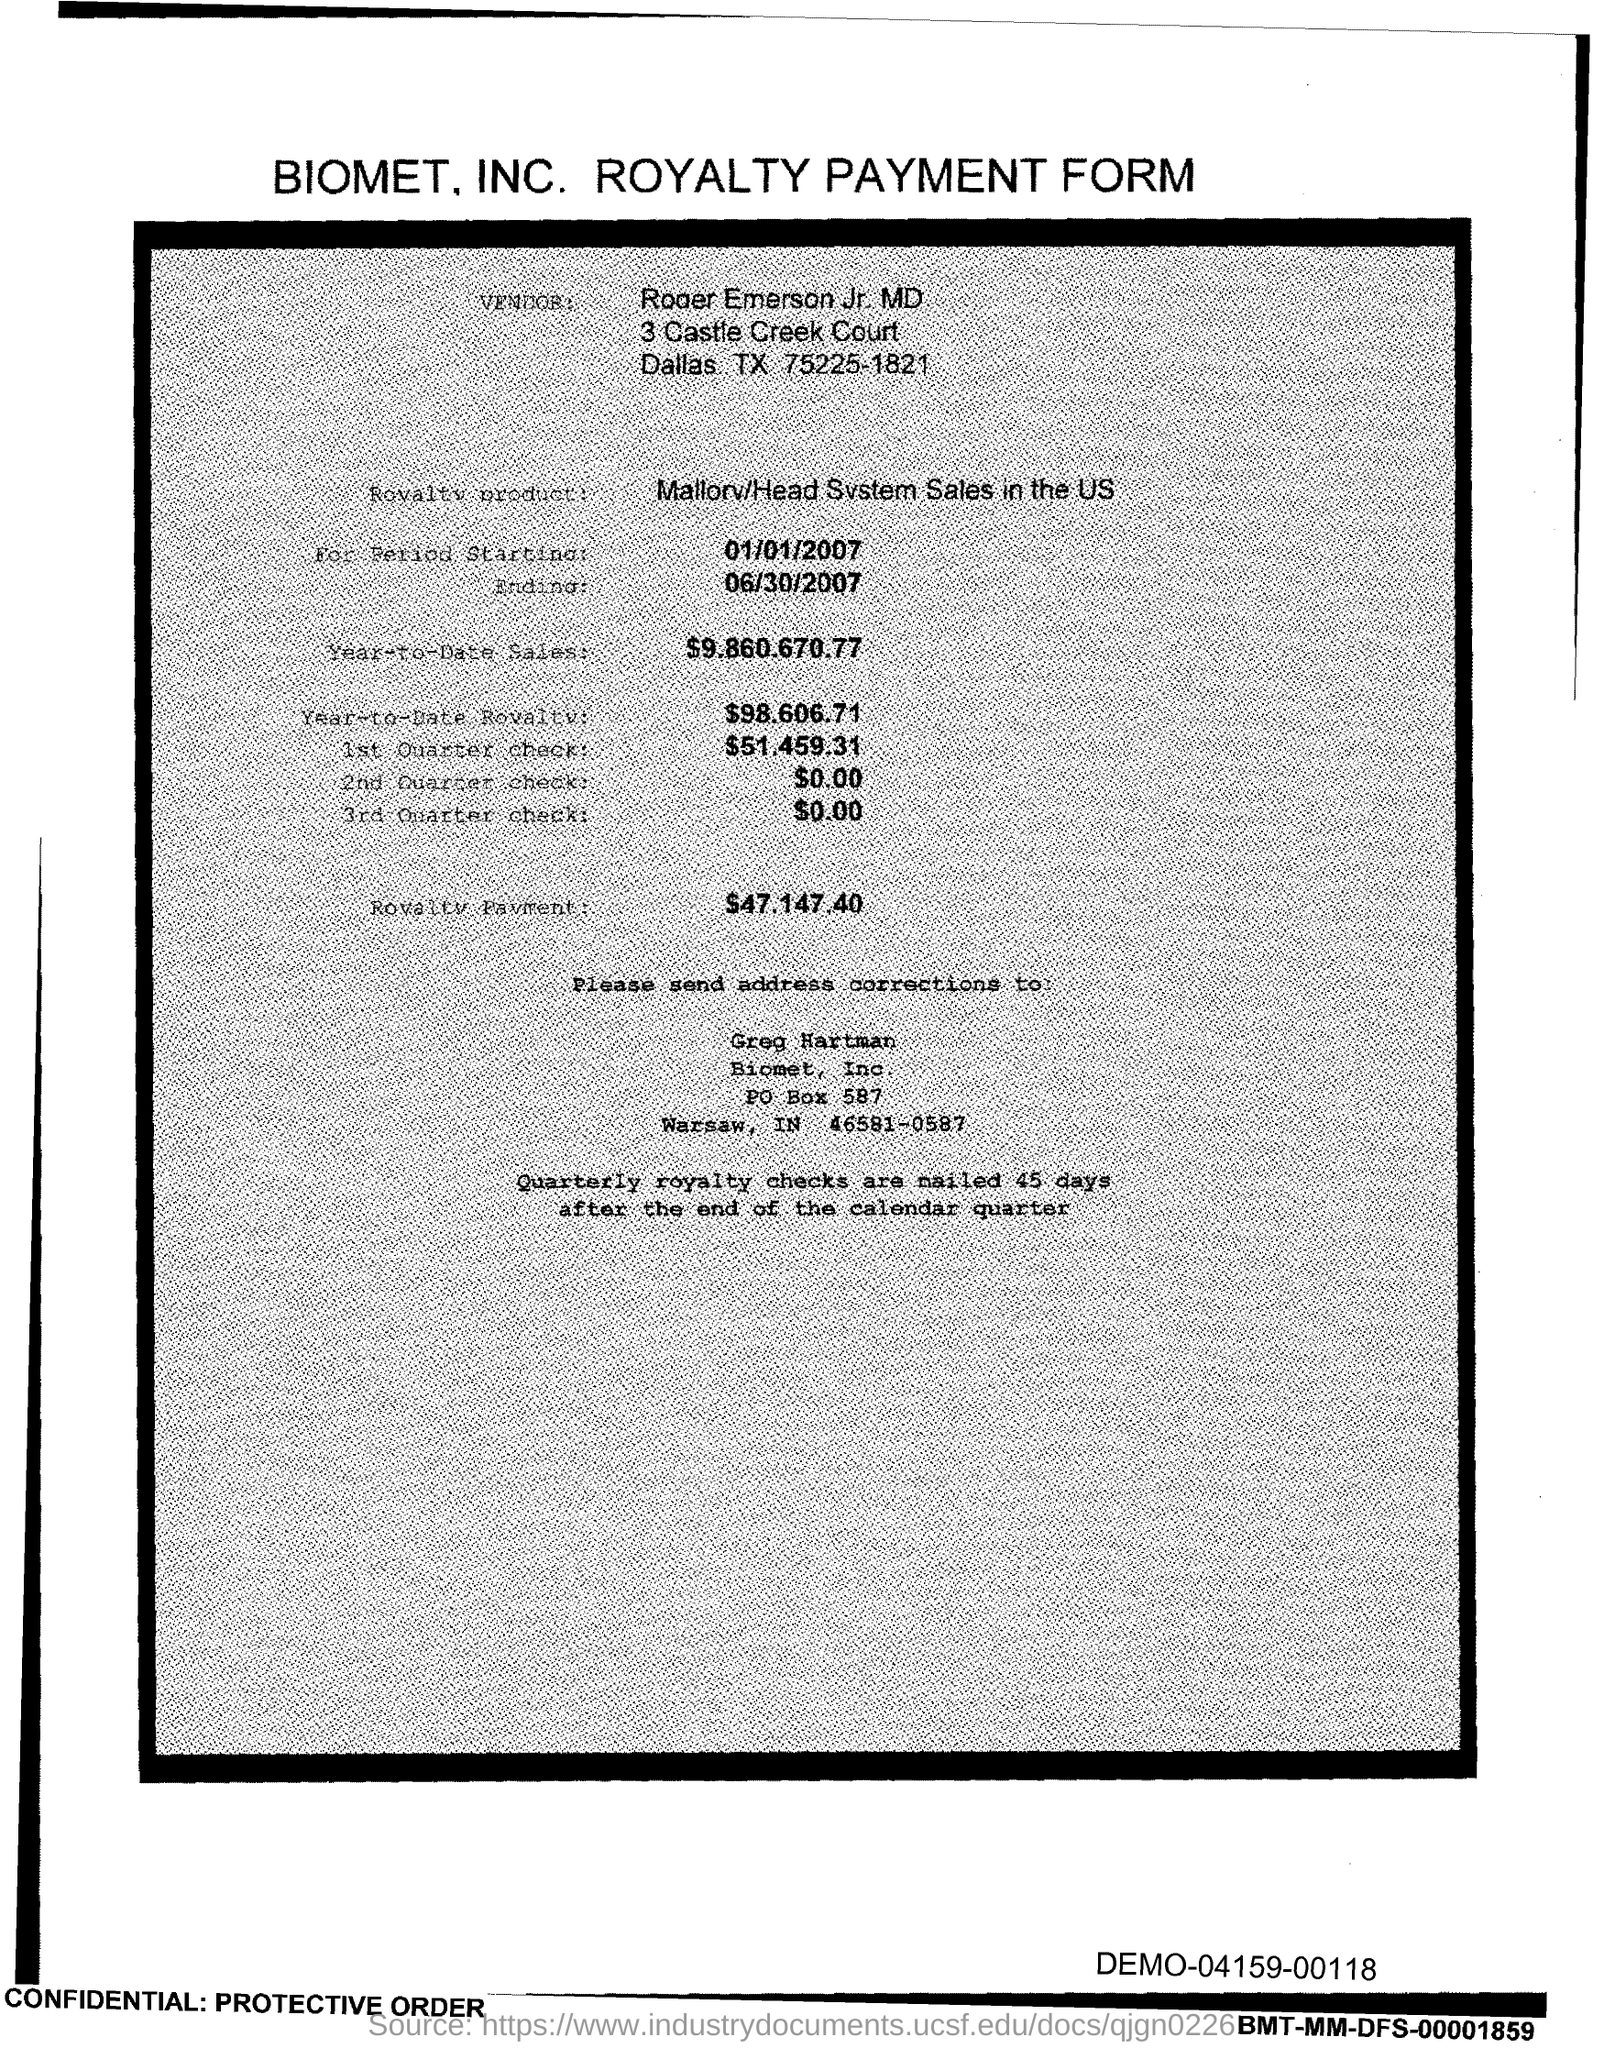Give some essential details in this illustration. This form is titled 'Biomet, INC. Royalty Payment Form.' 